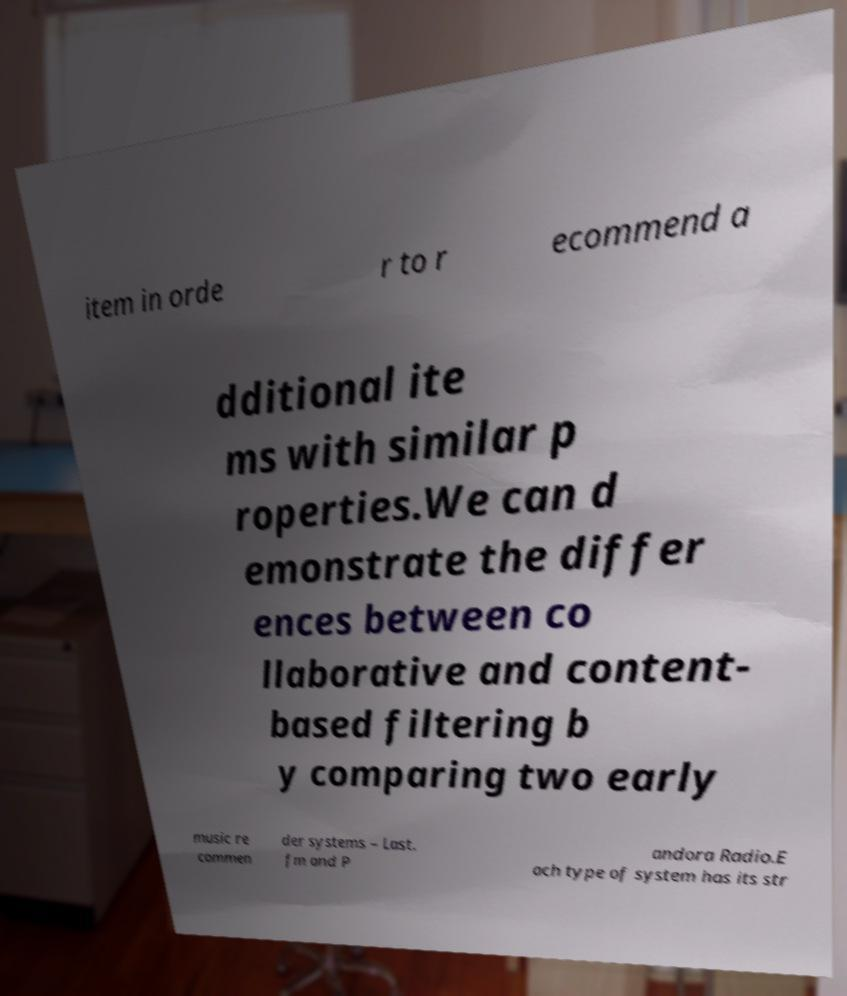What messages or text are displayed in this image? I need them in a readable, typed format. item in orde r to r ecommend a dditional ite ms with similar p roperties.We can d emonstrate the differ ences between co llaborative and content- based filtering b y comparing two early music re commen der systems – Last. fm and P andora Radio.E ach type of system has its str 